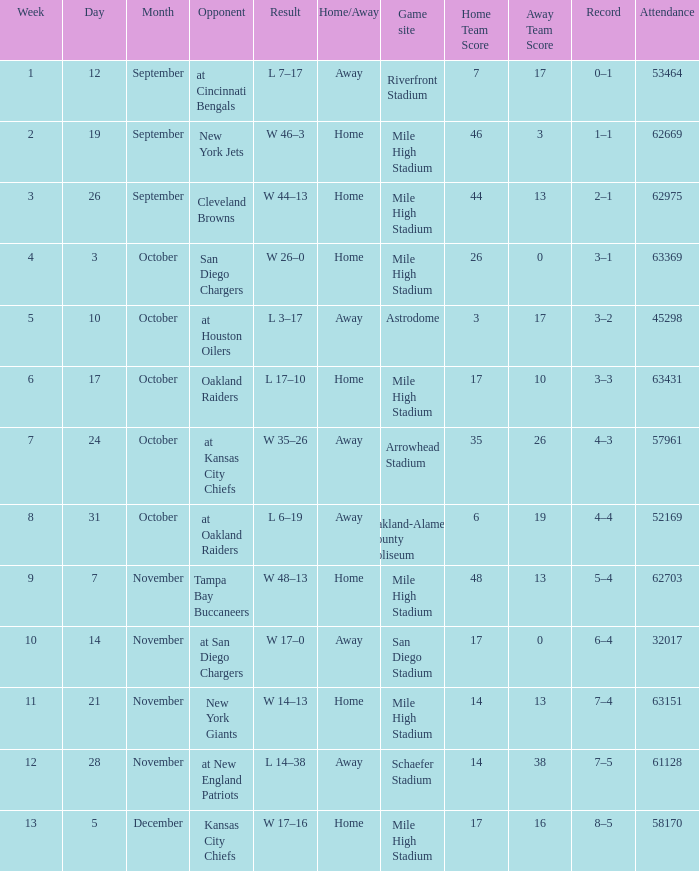What was the week number when the opponent was the New York Jets? 2.0. 